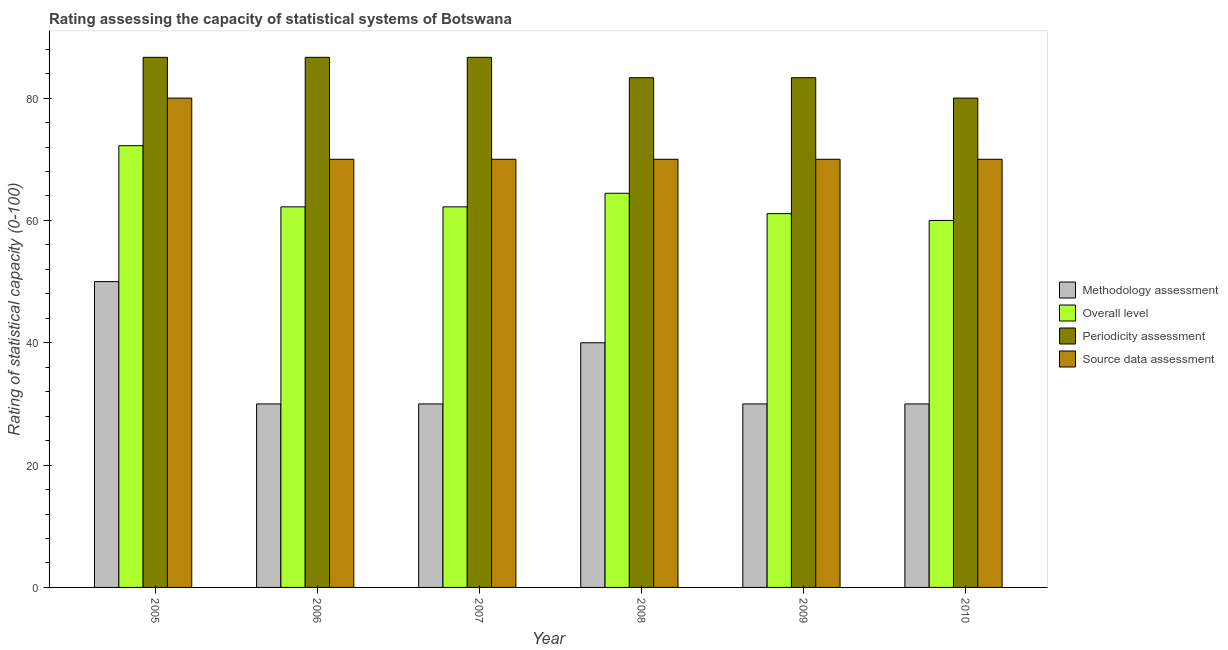How many different coloured bars are there?
Provide a succinct answer. 4. Are the number of bars on each tick of the X-axis equal?
Provide a short and direct response. Yes. How many bars are there on the 6th tick from the right?
Offer a terse response. 4. What is the methodology assessment rating in 2010?
Provide a short and direct response. 30. Across all years, what is the maximum source data assessment rating?
Your answer should be very brief. 80. Across all years, what is the minimum methodology assessment rating?
Make the answer very short. 30. What is the total overall level rating in the graph?
Provide a succinct answer. 382.22. What is the difference between the source data assessment rating in 2005 and that in 2007?
Provide a succinct answer. 10. What is the difference between the methodology assessment rating in 2008 and the overall level rating in 2006?
Offer a terse response. 10. What is the average methodology assessment rating per year?
Ensure brevity in your answer.  35. In the year 2010, what is the difference between the source data assessment rating and methodology assessment rating?
Your response must be concise. 0. Is the periodicity assessment rating in 2006 less than that in 2007?
Your response must be concise. No. What is the difference between the highest and the lowest source data assessment rating?
Offer a terse response. 10. Is the sum of the overall level rating in 2007 and 2008 greater than the maximum periodicity assessment rating across all years?
Give a very brief answer. Yes. Is it the case that in every year, the sum of the periodicity assessment rating and overall level rating is greater than the sum of methodology assessment rating and source data assessment rating?
Keep it short and to the point. No. What does the 2nd bar from the left in 2005 represents?
Provide a short and direct response. Overall level. What does the 1st bar from the right in 2005 represents?
Your response must be concise. Source data assessment. Is it the case that in every year, the sum of the methodology assessment rating and overall level rating is greater than the periodicity assessment rating?
Your response must be concise. Yes. How many bars are there?
Offer a terse response. 24. How many years are there in the graph?
Keep it short and to the point. 6. Are the values on the major ticks of Y-axis written in scientific E-notation?
Make the answer very short. No. Does the graph contain grids?
Your answer should be very brief. No. Where does the legend appear in the graph?
Offer a very short reply. Center right. How many legend labels are there?
Offer a very short reply. 4. What is the title of the graph?
Your answer should be compact. Rating assessing the capacity of statistical systems of Botswana. Does "Burnt food" appear as one of the legend labels in the graph?
Give a very brief answer. No. What is the label or title of the Y-axis?
Offer a very short reply. Rating of statistical capacity (0-100). What is the Rating of statistical capacity (0-100) in Overall level in 2005?
Give a very brief answer. 72.22. What is the Rating of statistical capacity (0-100) in Periodicity assessment in 2005?
Your answer should be very brief. 86.67. What is the Rating of statistical capacity (0-100) of Overall level in 2006?
Your response must be concise. 62.22. What is the Rating of statistical capacity (0-100) in Periodicity assessment in 2006?
Make the answer very short. 86.67. What is the Rating of statistical capacity (0-100) in Source data assessment in 2006?
Your answer should be very brief. 70. What is the Rating of statistical capacity (0-100) of Methodology assessment in 2007?
Provide a short and direct response. 30. What is the Rating of statistical capacity (0-100) of Overall level in 2007?
Offer a very short reply. 62.22. What is the Rating of statistical capacity (0-100) of Periodicity assessment in 2007?
Keep it short and to the point. 86.67. What is the Rating of statistical capacity (0-100) of Source data assessment in 2007?
Give a very brief answer. 70. What is the Rating of statistical capacity (0-100) in Overall level in 2008?
Provide a short and direct response. 64.44. What is the Rating of statistical capacity (0-100) in Periodicity assessment in 2008?
Provide a short and direct response. 83.33. What is the Rating of statistical capacity (0-100) in Source data assessment in 2008?
Offer a terse response. 70. What is the Rating of statistical capacity (0-100) of Overall level in 2009?
Offer a very short reply. 61.11. What is the Rating of statistical capacity (0-100) of Periodicity assessment in 2009?
Keep it short and to the point. 83.33. What is the Rating of statistical capacity (0-100) of Methodology assessment in 2010?
Make the answer very short. 30. What is the Rating of statistical capacity (0-100) in Periodicity assessment in 2010?
Your answer should be very brief. 80. What is the Rating of statistical capacity (0-100) of Source data assessment in 2010?
Offer a terse response. 70. Across all years, what is the maximum Rating of statistical capacity (0-100) of Methodology assessment?
Your answer should be compact. 50. Across all years, what is the maximum Rating of statistical capacity (0-100) of Overall level?
Provide a short and direct response. 72.22. Across all years, what is the maximum Rating of statistical capacity (0-100) in Periodicity assessment?
Provide a succinct answer. 86.67. Across all years, what is the minimum Rating of statistical capacity (0-100) of Methodology assessment?
Keep it short and to the point. 30. Across all years, what is the minimum Rating of statistical capacity (0-100) of Periodicity assessment?
Your response must be concise. 80. Across all years, what is the minimum Rating of statistical capacity (0-100) of Source data assessment?
Offer a terse response. 70. What is the total Rating of statistical capacity (0-100) in Methodology assessment in the graph?
Offer a very short reply. 210. What is the total Rating of statistical capacity (0-100) in Overall level in the graph?
Offer a terse response. 382.22. What is the total Rating of statistical capacity (0-100) in Periodicity assessment in the graph?
Offer a very short reply. 506.67. What is the total Rating of statistical capacity (0-100) of Source data assessment in the graph?
Provide a succinct answer. 430. What is the difference between the Rating of statistical capacity (0-100) in Methodology assessment in 2005 and that in 2006?
Ensure brevity in your answer.  20. What is the difference between the Rating of statistical capacity (0-100) of Periodicity assessment in 2005 and that in 2006?
Offer a very short reply. 0. What is the difference between the Rating of statistical capacity (0-100) in Periodicity assessment in 2005 and that in 2007?
Offer a terse response. 0. What is the difference between the Rating of statistical capacity (0-100) of Source data assessment in 2005 and that in 2007?
Your response must be concise. 10. What is the difference between the Rating of statistical capacity (0-100) of Methodology assessment in 2005 and that in 2008?
Ensure brevity in your answer.  10. What is the difference between the Rating of statistical capacity (0-100) in Overall level in 2005 and that in 2008?
Give a very brief answer. 7.78. What is the difference between the Rating of statistical capacity (0-100) of Methodology assessment in 2005 and that in 2009?
Your response must be concise. 20. What is the difference between the Rating of statistical capacity (0-100) in Overall level in 2005 and that in 2009?
Your answer should be compact. 11.11. What is the difference between the Rating of statistical capacity (0-100) of Source data assessment in 2005 and that in 2009?
Offer a terse response. 10. What is the difference between the Rating of statistical capacity (0-100) of Methodology assessment in 2005 and that in 2010?
Your answer should be very brief. 20. What is the difference between the Rating of statistical capacity (0-100) in Overall level in 2005 and that in 2010?
Make the answer very short. 12.22. What is the difference between the Rating of statistical capacity (0-100) in Periodicity assessment in 2005 and that in 2010?
Ensure brevity in your answer.  6.67. What is the difference between the Rating of statistical capacity (0-100) in Source data assessment in 2005 and that in 2010?
Provide a short and direct response. 10. What is the difference between the Rating of statistical capacity (0-100) in Source data assessment in 2006 and that in 2007?
Your answer should be very brief. 0. What is the difference between the Rating of statistical capacity (0-100) in Overall level in 2006 and that in 2008?
Give a very brief answer. -2.22. What is the difference between the Rating of statistical capacity (0-100) of Periodicity assessment in 2006 and that in 2008?
Give a very brief answer. 3.33. What is the difference between the Rating of statistical capacity (0-100) of Overall level in 2006 and that in 2010?
Make the answer very short. 2.22. What is the difference between the Rating of statistical capacity (0-100) in Methodology assessment in 2007 and that in 2008?
Provide a succinct answer. -10. What is the difference between the Rating of statistical capacity (0-100) of Overall level in 2007 and that in 2008?
Ensure brevity in your answer.  -2.22. What is the difference between the Rating of statistical capacity (0-100) in Periodicity assessment in 2007 and that in 2009?
Provide a short and direct response. 3.33. What is the difference between the Rating of statistical capacity (0-100) in Methodology assessment in 2007 and that in 2010?
Offer a very short reply. 0. What is the difference between the Rating of statistical capacity (0-100) of Overall level in 2007 and that in 2010?
Your response must be concise. 2.22. What is the difference between the Rating of statistical capacity (0-100) in Periodicity assessment in 2007 and that in 2010?
Ensure brevity in your answer.  6.67. What is the difference between the Rating of statistical capacity (0-100) of Source data assessment in 2007 and that in 2010?
Give a very brief answer. 0. What is the difference between the Rating of statistical capacity (0-100) in Methodology assessment in 2008 and that in 2009?
Your response must be concise. 10. What is the difference between the Rating of statistical capacity (0-100) in Overall level in 2008 and that in 2009?
Provide a short and direct response. 3.33. What is the difference between the Rating of statistical capacity (0-100) of Periodicity assessment in 2008 and that in 2009?
Offer a terse response. 0. What is the difference between the Rating of statistical capacity (0-100) of Overall level in 2008 and that in 2010?
Offer a very short reply. 4.44. What is the difference between the Rating of statistical capacity (0-100) of Source data assessment in 2008 and that in 2010?
Ensure brevity in your answer.  0. What is the difference between the Rating of statistical capacity (0-100) of Methodology assessment in 2009 and that in 2010?
Your answer should be compact. 0. What is the difference between the Rating of statistical capacity (0-100) in Overall level in 2009 and that in 2010?
Provide a succinct answer. 1.11. What is the difference between the Rating of statistical capacity (0-100) in Methodology assessment in 2005 and the Rating of statistical capacity (0-100) in Overall level in 2006?
Provide a short and direct response. -12.22. What is the difference between the Rating of statistical capacity (0-100) in Methodology assessment in 2005 and the Rating of statistical capacity (0-100) in Periodicity assessment in 2006?
Your answer should be compact. -36.67. What is the difference between the Rating of statistical capacity (0-100) in Overall level in 2005 and the Rating of statistical capacity (0-100) in Periodicity assessment in 2006?
Provide a short and direct response. -14.44. What is the difference between the Rating of statistical capacity (0-100) in Overall level in 2005 and the Rating of statistical capacity (0-100) in Source data assessment in 2006?
Ensure brevity in your answer.  2.22. What is the difference between the Rating of statistical capacity (0-100) in Periodicity assessment in 2005 and the Rating of statistical capacity (0-100) in Source data assessment in 2006?
Your answer should be compact. 16.67. What is the difference between the Rating of statistical capacity (0-100) in Methodology assessment in 2005 and the Rating of statistical capacity (0-100) in Overall level in 2007?
Offer a terse response. -12.22. What is the difference between the Rating of statistical capacity (0-100) in Methodology assessment in 2005 and the Rating of statistical capacity (0-100) in Periodicity assessment in 2007?
Keep it short and to the point. -36.67. What is the difference between the Rating of statistical capacity (0-100) in Methodology assessment in 2005 and the Rating of statistical capacity (0-100) in Source data assessment in 2007?
Offer a terse response. -20. What is the difference between the Rating of statistical capacity (0-100) in Overall level in 2005 and the Rating of statistical capacity (0-100) in Periodicity assessment in 2007?
Provide a succinct answer. -14.44. What is the difference between the Rating of statistical capacity (0-100) of Overall level in 2005 and the Rating of statistical capacity (0-100) of Source data assessment in 2007?
Provide a short and direct response. 2.22. What is the difference between the Rating of statistical capacity (0-100) in Periodicity assessment in 2005 and the Rating of statistical capacity (0-100) in Source data assessment in 2007?
Provide a succinct answer. 16.67. What is the difference between the Rating of statistical capacity (0-100) of Methodology assessment in 2005 and the Rating of statistical capacity (0-100) of Overall level in 2008?
Provide a succinct answer. -14.44. What is the difference between the Rating of statistical capacity (0-100) in Methodology assessment in 2005 and the Rating of statistical capacity (0-100) in Periodicity assessment in 2008?
Your answer should be compact. -33.33. What is the difference between the Rating of statistical capacity (0-100) in Methodology assessment in 2005 and the Rating of statistical capacity (0-100) in Source data assessment in 2008?
Keep it short and to the point. -20. What is the difference between the Rating of statistical capacity (0-100) of Overall level in 2005 and the Rating of statistical capacity (0-100) of Periodicity assessment in 2008?
Offer a terse response. -11.11. What is the difference between the Rating of statistical capacity (0-100) of Overall level in 2005 and the Rating of statistical capacity (0-100) of Source data assessment in 2008?
Provide a short and direct response. 2.22. What is the difference between the Rating of statistical capacity (0-100) of Periodicity assessment in 2005 and the Rating of statistical capacity (0-100) of Source data assessment in 2008?
Your answer should be compact. 16.67. What is the difference between the Rating of statistical capacity (0-100) of Methodology assessment in 2005 and the Rating of statistical capacity (0-100) of Overall level in 2009?
Provide a short and direct response. -11.11. What is the difference between the Rating of statistical capacity (0-100) of Methodology assessment in 2005 and the Rating of statistical capacity (0-100) of Periodicity assessment in 2009?
Your answer should be very brief. -33.33. What is the difference between the Rating of statistical capacity (0-100) of Methodology assessment in 2005 and the Rating of statistical capacity (0-100) of Source data assessment in 2009?
Offer a terse response. -20. What is the difference between the Rating of statistical capacity (0-100) of Overall level in 2005 and the Rating of statistical capacity (0-100) of Periodicity assessment in 2009?
Your response must be concise. -11.11. What is the difference between the Rating of statistical capacity (0-100) in Overall level in 2005 and the Rating of statistical capacity (0-100) in Source data assessment in 2009?
Provide a succinct answer. 2.22. What is the difference between the Rating of statistical capacity (0-100) in Periodicity assessment in 2005 and the Rating of statistical capacity (0-100) in Source data assessment in 2009?
Your answer should be compact. 16.67. What is the difference between the Rating of statistical capacity (0-100) in Overall level in 2005 and the Rating of statistical capacity (0-100) in Periodicity assessment in 2010?
Provide a short and direct response. -7.78. What is the difference between the Rating of statistical capacity (0-100) in Overall level in 2005 and the Rating of statistical capacity (0-100) in Source data assessment in 2010?
Your answer should be very brief. 2.22. What is the difference between the Rating of statistical capacity (0-100) of Periodicity assessment in 2005 and the Rating of statistical capacity (0-100) of Source data assessment in 2010?
Give a very brief answer. 16.67. What is the difference between the Rating of statistical capacity (0-100) in Methodology assessment in 2006 and the Rating of statistical capacity (0-100) in Overall level in 2007?
Provide a succinct answer. -32.22. What is the difference between the Rating of statistical capacity (0-100) of Methodology assessment in 2006 and the Rating of statistical capacity (0-100) of Periodicity assessment in 2007?
Provide a short and direct response. -56.67. What is the difference between the Rating of statistical capacity (0-100) of Overall level in 2006 and the Rating of statistical capacity (0-100) of Periodicity assessment in 2007?
Keep it short and to the point. -24.44. What is the difference between the Rating of statistical capacity (0-100) of Overall level in 2006 and the Rating of statistical capacity (0-100) of Source data assessment in 2007?
Keep it short and to the point. -7.78. What is the difference between the Rating of statistical capacity (0-100) in Periodicity assessment in 2006 and the Rating of statistical capacity (0-100) in Source data assessment in 2007?
Provide a succinct answer. 16.67. What is the difference between the Rating of statistical capacity (0-100) of Methodology assessment in 2006 and the Rating of statistical capacity (0-100) of Overall level in 2008?
Keep it short and to the point. -34.44. What is the difference between the Rating of statistical capacity (0-100) in Methodology assessment in 2006 and the Rating of statistical capacity (0-100) in Periodicity assessment in 2008?
Offer a very short reply. -53.33. What is the difference between the Rating of statistical capacity (0-100) of Methodology assessment in 2006 and the Rating of statistical capacity (0-100) of Source data assessment in 2008?
Offer a terse response. -40. What is the difference between the Rating of statistical capacity (0-100) in Overall level in 2006 and the Rating of statistical capacity (0-100) in Periodicity assessment in 2008?
Your answer should be very brief. -21.11. What is the difference between the Rating of statistical capacity (0-100) in Overall level in 2006 and the Rating of statistical capacity (0-100) in Source data assessment in 2008?
Provide a short and direct response. -7.78. What is the difference between the Rating of statistical capacity (0-100) of Periodicity assessment in 2006 and the Rating of statistical capacity (0-100) of Source data assessment in 2008?
Give a very brief answer. 16.67. What is the difference between the Rating of statistical capacity (0-100) in Methodology assessment in 2006 and the Rating of statistical capacity (0-100) in Overall level in 2009?
Your answer should be compact. -31.11. What is the difference between the Rating of statistical capacity (0-100) of Methodology assessment in 2006 and the Rating of statistical capacity (0-100) of Periodicity assessment in 2009?
Keep it short and to the point. -53.33. What is the difference between the Rating of statistical capacity (0-100) of Methodology assessment in 2006 and the Rating of statistical capacity (0-100) of Source data assessment in 2009?
Give a very brief answer. -40. What is the difference between the Rating of statistical capacity (0-100) of Overall level in 2006 and the Rating of statistical capacity (0-100) of Periodicity assessment in 2009?
Keep it short and to the point. -21.11. What is the difference between the Rating of statistical capacity (0-100) of Overall level in 2006 and the Rating of statistical capacity (0-100) of Source data assessment in 2009?
Provide a short and direct response. -7.78. What is the difference between the Rating of statistical capacity (0-100) of Periodicity assessment in 2006 and the Rating of statistical capacity (0-100) of Source data assessment in 2009?
Your answer should be very brief. 16.67. What is the difference between the Rating of statistical capacity (0-100) in Methodology assessment in 2006 and the Rating of statistical capacity (0-100) in Source data assessment in 2010?
Offer a very short reply. -40. What is the difference between the Rating of statistical capacity (0-100) in Overall level in 2006 and the Rating of statistical capacity (0-100) in Periodicity assessment in 2010?
Provide a succinct answer. -17.78. What is the difference between the Rating of statistical capacity (0-100) in Overall level in 2006 and the Rating of statistical capacity (0-100) in Source data assessment in 2010?
Provide a succinct answer. -7.78. What is the difference between the Rating of statistical capacity (0-100) in Periodicity assessment in 2006 and the Rating of statistical capacity (0-100) in Source data assessment in 2010?
Keep it short and to the point. 16.67. What is the difference between the Rating of statistical capacity (0-100) of Methodology assessment in 2007 and the Rating of statistical capacity (0-100) of Overall level in 2008?
Offer a very short reply. -34.44. What is the difference between the Rating of statistical capacity (0-100) of Methodology assessment in 2007 and the Rating of statistical capacity (0-100) of Periodicity assessment in 2008?
Provide a succinct answer. -53.33. What is the difference between the Rating of statistical capacity (0-100) of Overall level in 2007 and the Rating of statistical capacity (0-100) of Periodicity assessment in 2008?
Provide a succinct answer. -21.11. What is the difference between the Rating of statistical capacity (0-100) in Overall level in 2007 and the Rating of statistical capacity (0-100) in Source data assessment in 2008?
Your answer should be compact. -7.78. What is the difference between the Rating of statistical capacity (0-100) of Periodicity assessment in 2007 and the Rating of statistical capacity (0-100) of Source data assessment in 2008?
Your response must be concise. 16.67. What is the difference between the Rating of statistical capacity (0-100) in Methodology assessment in 2007 and the Rating of statistical capacity (0-100) in Overall level in 2009?
Keep it short and to the point. -31.11. What is the difference between the Rating of statistical capacity (0-100) in Methodology assessment in 2007 and the Rating of statistical capacity (0-100) in Periodicity assessment in 2009?
Your response must be concise. -53.33. What is the difference between the Rating of statistical capacity (0-100) of Overall level in 2007 and the Rating of statistical capacity (0-100) of Periodicity assessment in 2009?
Your response must be concise. -21.11. What is the difference between the Rating of statistical capacity (0-100) of Overall level in 2007 and the Rating of statistical capacity (0-100) of Source data assessment in 2009?
Make the answer very short. -7.78. What is the difference between the Rating of statistical capacity (0-100) of Periodicity assessment in 2007 and the Rating of statistical capacity (0-100) of Source data assessment in 2009?
Your answer should be compact. 16.67. What is the difference between the Rating of statistical capacity (0-100) in Methodology assessment in 2007 and the Rating of statistical capacity (0-100) in Overall level in 2010?
Offer a very short reply. -30. What is the difference between the Rating of statistical capacity (0-100) in Overall level in 2007 and the Rating of statistical capacity (0-100) in Periodicity assessment in 2010?
Ensure brevity in your answer.  -17.78. What is the difference between the Rating of statistical capacity (0-100) of Overall level in 2007 and the Rating of statistical capacity (0-100) of Source data assessment in 2010?
Make the answer very short. -7.78. What is the difference between the Rating of statistical capacity (0-100) of Periodicity assessment in 2007 and the Rating of statistical capacity (0-100) of Source data assessment in 2010?
Your response must be concise. 16.67. What is the difference between the Rating of statistical capacity (0-100) in Methodology assessment in 2008 and the Rating of statistical capacity (0-100) in Overall level in 2009?
Provide a short and direct response. -21.11. What is the difference between the Rating of statistical capacity (0-100) of Methodology assessment in 2008 and the Rating of statistical capacity (0-100) of Periodicity assessment in 2009?
Offer a very short reply. -43.33. What is the difference between the Rating of statistical capacity (0-100) in Methodology assessment in 2008 and the Rating of statistical capacity (0-100) in Source data assessment in 2009?
Make the answer very short. -30. What is the difference between the Rating of statistical capacity (0-100) in Overall level in 2008 and the Rating of statistical capacity (0-100) in Periodicity assessment in 2009?
Ensure brevity in your answer.  -18.89. What is the difference between the Rating of statistical capacity (0-100) of Overall level in 2008 and the Rating of statistical capacity (0-100) of Source data assessment in 2009?
Provide a short and direct response. -5.56. What is the difference between the Rating of statistical capacity (0-100) of Periodicity assessment in 2008 and the Rating of statistical capacity (0-100) of Source data assessment in 2009?
Your answer should be very brief. 13.33. What is the difference between the Rating of statistical capacity (0-100) of Methodology assessment in 2008 and the Rating of statistical capacity (0-100) of Overall level in 2010?
Your answer should be very brief. -20. What is the difference between the Rating of statistical capacity (0-100) of Methodology assessment in 2008 and the Rating of statistical capacity (0-100) of Periodicity assessment in 2010?
Provide a short and direct response. -40. What is the difference between the Rating of statistical capacity (0-100) of Methodology assessment in 2008 and the Rating of statistical capacity (0-100) of Source data assessment in 2010?
Make the answer very short. -30. What is the difference between the Rating of statistical capacity (0-100) of Overall level in 2008 and the Rating of statistical capacity (0-100) of Periodicity assessment in 2010?
Make the answer very short. -15.56. What is the difference between the Rating of statistical capacity (0-100) in Overall level in 2008 and the Rating of statistical capacity (0-100) in Source data assessment in 2010?
Provide a short and direct response. -5.56. What is the difference between the Rating of statistical capacity (0-100) in Periodicity assessment in 2008 and the Rating of statistical capacity (0-100) in Source data assessment in 2010?
Provide a short and direct response. 13.33. What is the difference between the Rating of statistical capacity (0-100) of Methodology assessment in 2009 and the Rating of statistical capacity (0-100) of Source data assessment in 2010?
Offer a terse response. -40. What is the difference between the Rating of statistical capacity (0-100) in Overall level in 2009 and the Rating of statistical capacity (0-100) in Periodicity assessment in 2010?
Give a very brief answer. -18.89. What is the difference between the Rating of statistical capacity (0-100) of Overall level in 2009 and the Rating of statistical capacity (0-100) of Source data assessment in 2010?
Provide a succinct answer. -8.89. What is the difference between the Rating of statistical capacity (0-100) in Periodicity assessment in 2009 and the Rating of statistical capacity (0-100) in Source data assessment in 2010?
Offer a very short reply. 13.33. What is the average Rating of statistical capacity (0-100) of Overall level per year?
Your answer should be compact. 63.7. What is the average Rating of statistical capacity (0-100) in Periodicity assessment per year?
Offer a terse response. 84.44. What is the average Rating of statistical capacity (0-100) in Source data assessment per year?
Offer a very short reply. 71.67. In the year 2005, what is the difference between the Rating of statistical capacity (0-100) in Methodology assessment and Rating of statistical capacity (0-100) in Overall level?
Offer a very short reply. -22.22. In the year 2005, what is the difference between the Rating of statistical capacity (0-100) in Methodology assessment and Rating of statistical capacity (0-100) in Periodicity assessment?
Your answer should be compact. -36.67. In the year 2005, what is the difference between the Rating of statistical capacity (0-100) of Methodology assessment and Rating of statistical capacity (0-100) of Source data assessment?
Offer a terse response. -30. In the year 2005, what is the difference between the Rating of statistical capacity (0-100) of Overall level and Rating of statistical capacity (0-100) of Periodicity assessment?
Provide a succinct answer. -14.44. In the year 2005, what is the difference between the Rating of statistical capacity (0-100) of Overall level and Rating of statistical capacity (0-100) of Source data assessment?
Make the answer very short. -7.78. In the year 2006, what is the difference between the Rating of statistical capacity (0-100) of Methodology assessment and Rating of statistical capacity (0-100) of Overall level?
Keep it short and to the point. -32.22. In the year 2006, what is the difference between the Rating of statistical capacity (0-100) of Methodology assessment and Rating of statistical capacity (0-100) of Periodicity assessment?
Offer a terse response. -56.67. In the year 2006, what is the difference between the Rating of statistical capacity (0-100) of Methodology assessment and Rating of statistical capacity (0-100) of Source data assessment?
Give a very brief answer. -40. In the year 2006, what is the difference between the Rating of statistical capacity (0-100) of Overall level and Rating of statistical capacity (0-100) of Periodicity assessment?
Provide a short and direct response. -24.44. In the year 2006, what is the difference between the Rating of statistical capacity (0-100) in Overall level and Rating of statistical capacity (0-100) in Source data assessment?
Provide a succinct answer. -7.78. In the year 2006, what is the difference between the Rating of statistical capacity (0-100) of Periodicity assessment and Rating of statistical capacity (0-100) of Source data assessment?
Offer a terse response. 16.67. In the year 2007, what is the difference between the Rating of statistical capacity (0-100) of Methodology assessment and Rating of statistical capacity (0-100) of Overall level?
Ensure brevity in your answer.  -32.22. In the year 2007, what is the difference between the Rating of statistical capacity (0-100) in Methodology assessment and Rating of statistical capacity (0-100) in Periodicity assessment?
Keep it short and to the point. -56.67. In the year 2007, what is the difference between the Rating of statistical capacity (0-100) in Overall level and Rating of statistical capacity (0-100) in Periodicity assessment?
Provide a succinct answer. -24.44. In the year 2007, what is the difference between the Rating of statistical capacity (0-100) in Overall level and Rating of statistical capacity (0-100) in Source data assessment?
Your response must be concise. -7.78. In the year 2007, what is the difference between the Rating of statistical capacity (0-100) of Periodicity assessment and Rating of statistical capacity (0-100) of Source data assessment?
Keep it short and to the point. 16.67. In the year 2008, what is the difference between the Rating of statistical capacity (0-100) in Methodology assessment and Rating of statistical capacity (0-100) in Overall level?
Your response must be concise. -24.44. In the year 2008, what is the difference between the Rating of statistical capacity (0-100) in Methodology assessment and Rating of statistical capacity (0-100) in Periodicity assessment?
Make the answer very short. -43.33. In the year 2008, what is the difference between the Rating of statistical capacity (0-100) in Methodology assessment and Rating of statistical capacity (0-100) in Source data assessment?
Provide a succinct answer. -30. In the year 2008, what is the difference between the Rating of statistical capacity (0-100) of Overall level and Rating of statistical capacity (0-100) of Periodicity assessment?
Make the answer very short. -18.89. In the year 2008, what is the difference between the Rating of statistical capacity (0-100) of Overall level and Rating of statistical capacity (0-100) of Source data assessment?
Make the answer very short. -5.56. In the year 2008, what is the difference between the Rating of statistical capacity (0-100) of Periodicity assessment and Rating of statistical capacity (0-100) of Source data assessment?
Provide a short and direct response. 13.33. In the year 2009, what is the difference between the Rating of statistical capacity (0-100) of Methodology assessment and Rating of statistical capacity (0-100) of Overall level?
Keep it short and to the point. -31.11. In the year 2009, what is the difference between the Rating of statistical capacity (0-100) in Methodology assessment and Rating of statistical capacity (0-100) in Periodicity assessment?
Provide a short and direct response. -53.33. In the year 2009, what is the difference between the Rating of statistical capacity (0-100) of Methodology assessment and Rating of statistical capacity (0-100) of Source data assessment?
Make the answer very short. -40. In the year 2009, what is the difference between the Rating of statistical capacity (0-100) in Overall level and Rating of statistical capacity (0-100) in Periodicity assessment?
Keep it short and to the point. -22.22. In the year 2009, what is the difference between the Rating of statistical capacity (0-100) in Overall level and Rating of statistical capacity (0-100) in Source data assessment?
Provide a succinct answer. -8.89. In the year 2009, what is the difference between the Rating of statistical capacity (0-100) of Periodicity assessment and Rating of statistical capacity (0-100) of Source data assessment?
Your answer should be very brief. 13.33. In the year 2010, what is the difference between the Rating of statistical capacity (0-100) of Methodology assessment and Rating of statistical capacity (0-100) of Overall level?
Your answer should be very brief. -30. In the year 2010, what is the difference between the Rating of statistical capacity (0-100) in Methodology assessment and Rating of statistical capacity (0-100) in Source data assessment?
Offer a very short reply. -40. In the year 2010, what is the difference between the Rating of statistical capacity (0-100) of Overall level and Rating of statistical capacity (0-100) of Periodicity assessment?
Ensure brevity in your answer.  -20. What is the ratio of the Rating of statistical capacity (0-100) of Overall level in 2005 to that in 2006?
Make the answer very short. 1.16. What is the ratio of the Rating of statistical capacity (0-100) of Periodicity assessment in 2005 to that in 2006?
Your answer should be compact. 1. What is the ratio of the Rating of statistical capacity (0-100) in Overall level in 2005 to that in 2007?
Your answer should be very brief. 1.16. What is the ratio of the Rating of statistical capacity (0-100) in Periodicity assessment in 2005 to that in 2007?
Ensure brevity in your answer.  1. What is the ratio of the Rating of statistical capacity (0-100) of Source data assessment in 2005 to that in 2007?
Your answer should be compact. 1.14. What is the ratio of the Rating of statistical capacity (0-100) of Overall level in 2005 to that in 2008?
Ensure brevity in your answer.  1.12. What is the ratio of the Rating of statistical capacity (0-100) in Periodicity assessment in 2005 to that in 2008?
Your response must be concise. 1.04. What is the ratio of the Rating of statistical capacity (0-100) in Source data assessment in 2005 to that in 2008?
Your response must be concise. 1.14. What is the ratio of the Rating of statistical capacity (0-100) of Overall level in 2005 to that in 2009?
Keep it short and to the point. 1.18. What is the ratio of the Rating of statistical capacity (0-100) in Methodology assessment in 2005 to that in 2010?
Your answer should be very brief. 1.67. What is the ratio of the Rating of statistical capacity (0-100) of Overall level in 2005 to that in 2010?
Your answer should be very brief. 1.2. What is the ratio of the Rating of statistical capacity (0-100) in Periodicity assessment in 2005 to that in 2010?
Make the answer very short. 1.08. What is the ratio of the Rating of statistical capacity (0-100) in Methodology assessment in 2006 to that in 2007?
Your response must be concise. 1. What is the ratio of the Rating of statistical capacity (0-100) of Overall level in 2006 to that in 2007?
Your answer should be compact. 1. What is the ratio of the Rating of statistical capacity (0-100) of Overall level in 2006 to that in 2008?
Provide a succinct answer. 0.97. What is the ratio of the Rating of statistical capacity (0-100) of Periodicity assessment in 2006 to that in 2008?
Provide a short and direct response. 1.04. What is the ratio of the Rating of statistical capacity (0-100) of Methodology assessment in 2006 to that in 2009?
Ensure brevity in your answer.  1. What is the ratio of the Rating of statistical capacity (0-100) of Overall level in 2006 to that in 2009?
Ensure brevity in your answer.  1.02. What is the ratio of the Rating of statistical capacity (0-100) in Methodology assessment in 2006 to that in 2010?
Your answer should be compact. 1. What is the ratio of the Rating of statistical capacity (0-100) in Overall level in 2007 to that in 2008?
Provide a short and direct response. 0.97. What is the ratio of the Rating of statistical capacity (0-100) in Periodicity assessment in 2007 to that in 2008?
Offer a very short reply. 1.04. What is the ratio of the Rating of statistical capacity (0-100) in Source data assessment in 2007 to that in 2008?
Offer a very short reply. 1. What is the ratio of the Rating of statistical capacity (0-100) of Overall level in 2007 to that in 2009?
Provide a succinct answer. 1.02. What is the ratio of the Rating of statistical capacity (0-100) in Periodicity assessment in 2007 to that in 2009?
Make the answer very short. 1.04. What is the ratio of the Rating of statistical capacity (0-100) of Source data assessment in 2007 to that in 2009?
Keep it short and to the point. 1. What is the ratio of the Rating of statistical capacity (0-100) of Overall level in 2007 to that in 2010?
Provide a short and direct response. 1.04. What is the ratio of the Rating of statistical capacity (0-100) of Periodicity assessment in 2007 to that in 2010?
Your response must be concise. 1.08. What is the ratio of the Rating of statistical capacity (0-100) of Overall level in 2008 to that in 2009?
Provide a succinct answer. 1.05. What is the ratio of the Rating of statistical capacity (0-100) of Source data assessment in 2008 to that in 2009?
Your answer should be compact. 1. What is the ratio of the Rating of statistical capacity (0-100) of Methodology assessment in 2008 to that in 2010?
Provide a succinct answer. 1.33. What is the ratio of the Rating of statistical capacity (0-100) in Overall level in 2008 to that in 2010?
Offer a terse response. 1.07. What is the ratio of the Rating of statistical capacity (0-100) in Periodicity assessment in 2008 to that in 2010?
Your answer should be compact. 1.04. What is the ratio of the Rating of statistical capacity (0-100) in Methodology assessment in 2009 to that in 2010?
Give a very brief answer. 1. What is the ratio of the Rating of statistical capacity (0-100) of Overall level in 2009 to that in 2010?
Give a very brief answer. 1.02. What is the ratio of the Rating of statistical capacity (0-100) of Periodicity assessment in 2009 to that in 2010?
Ensure brevity in your answer.  1.04. What is the difference between the highest and the second highest Rating of statistical capacity (0-100) of Overall level?
Offer a terse response. 7.78. What is the difference between the highest and the second highest Rating of statistical capacity (0-100) of Periodicity assessment?
Your answer should be compact. 0. What is the difference between the highest and the second highest Rating of statistical capacity (0-100) in Source data assessment?
Ensure brevity in your answer.  10. What is the difference between the highest and the lowest Rating of statistical capacity (0-100) of Overall level?
Your response must be concise. 12.22. 